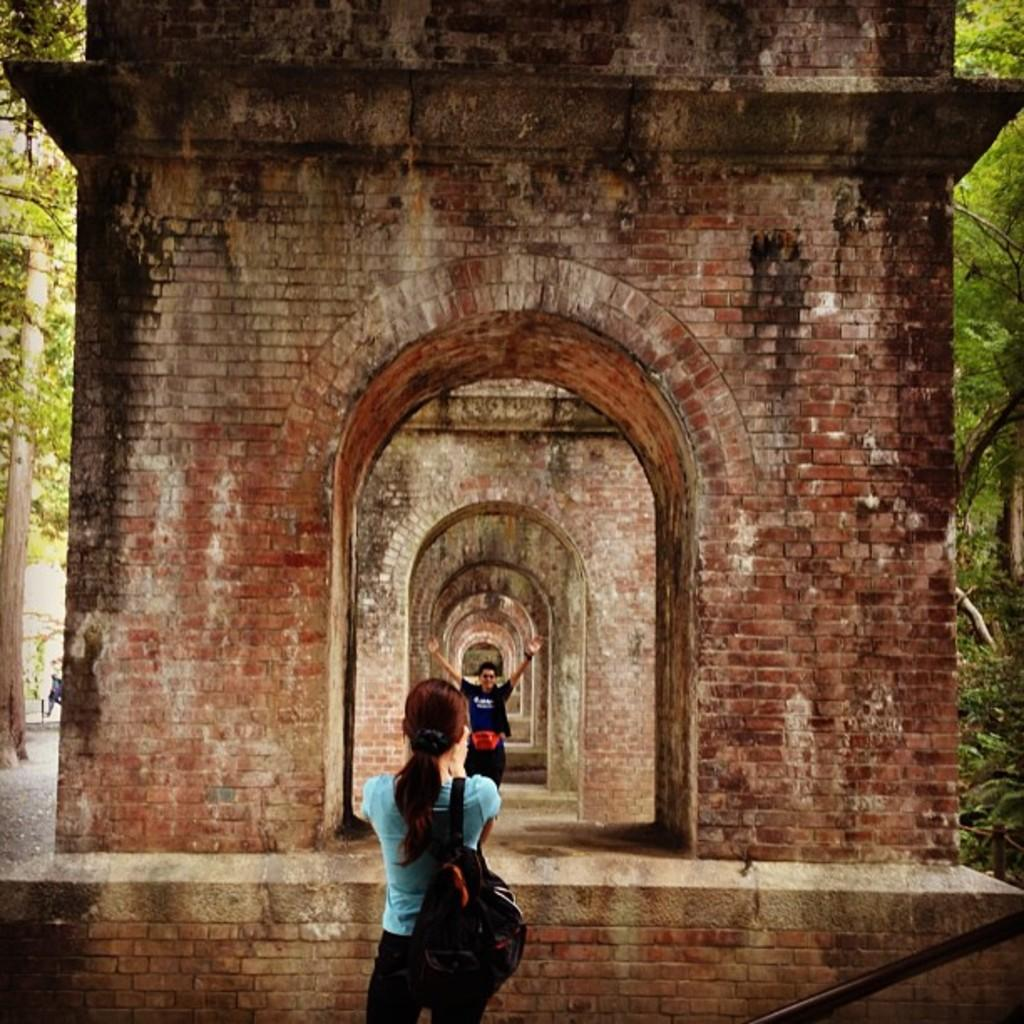Who is the main subject in the image? There is a woman in the image. What is the woman doing in the image? The woman is clicking a picture of a person. What is in front of the woman in the image? There is a wall in front of the woman. What can be seen on either side of the wall in the image? There are trees on either side of the wall. How many pizzas are on the sink in the image? There is no sink or pizzas present in the image. 